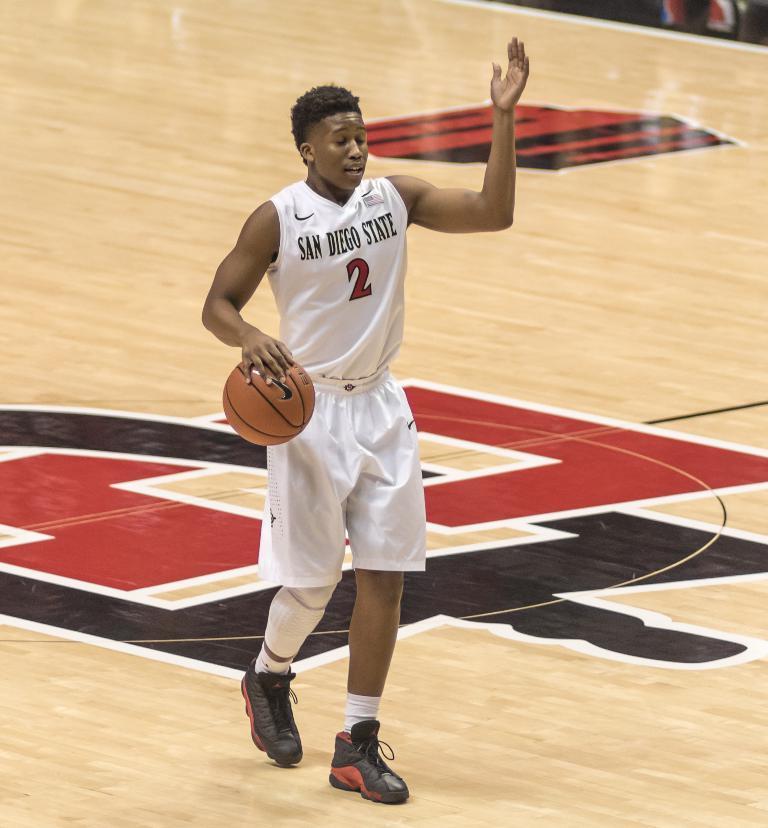Could you give a brief overview of what you see in this image? In this picture I can see a man in front, who is wearing a man in front, who is wearing white color jersey and I see that he is standing and I see a ball under his hand. On the tank top I see something is written and I see the basketball court. 